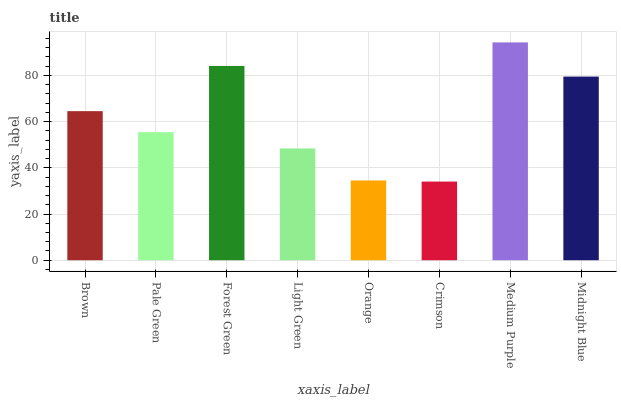Is Crimson the minimum?
Answer yes or no. Yes. Is Medium Purple the maximum?
Answer yes or no. Yes. Is Pale Green the minimum?
Answer yes or no. No. Is Pale Green the maximum?
Answer yes or no. No. Is Brown greater than Pale Green?
Answer yes or no. Yes. Is Pale Green less than Brown?
Answer yes or no. Yes. Is Pale Green greater than Brown?
Answer yes or no. No. Is Brown less than Pale Green?
Answer yes or no. No. Is Brown the high median?
Answer yes or no. Yes. Is Pale Green the low median?
Answer yes or no. Yes. Is Forest Green the high median?
Answer yes or no. No. Is Orange the low median?
Answer yes or no. No. 